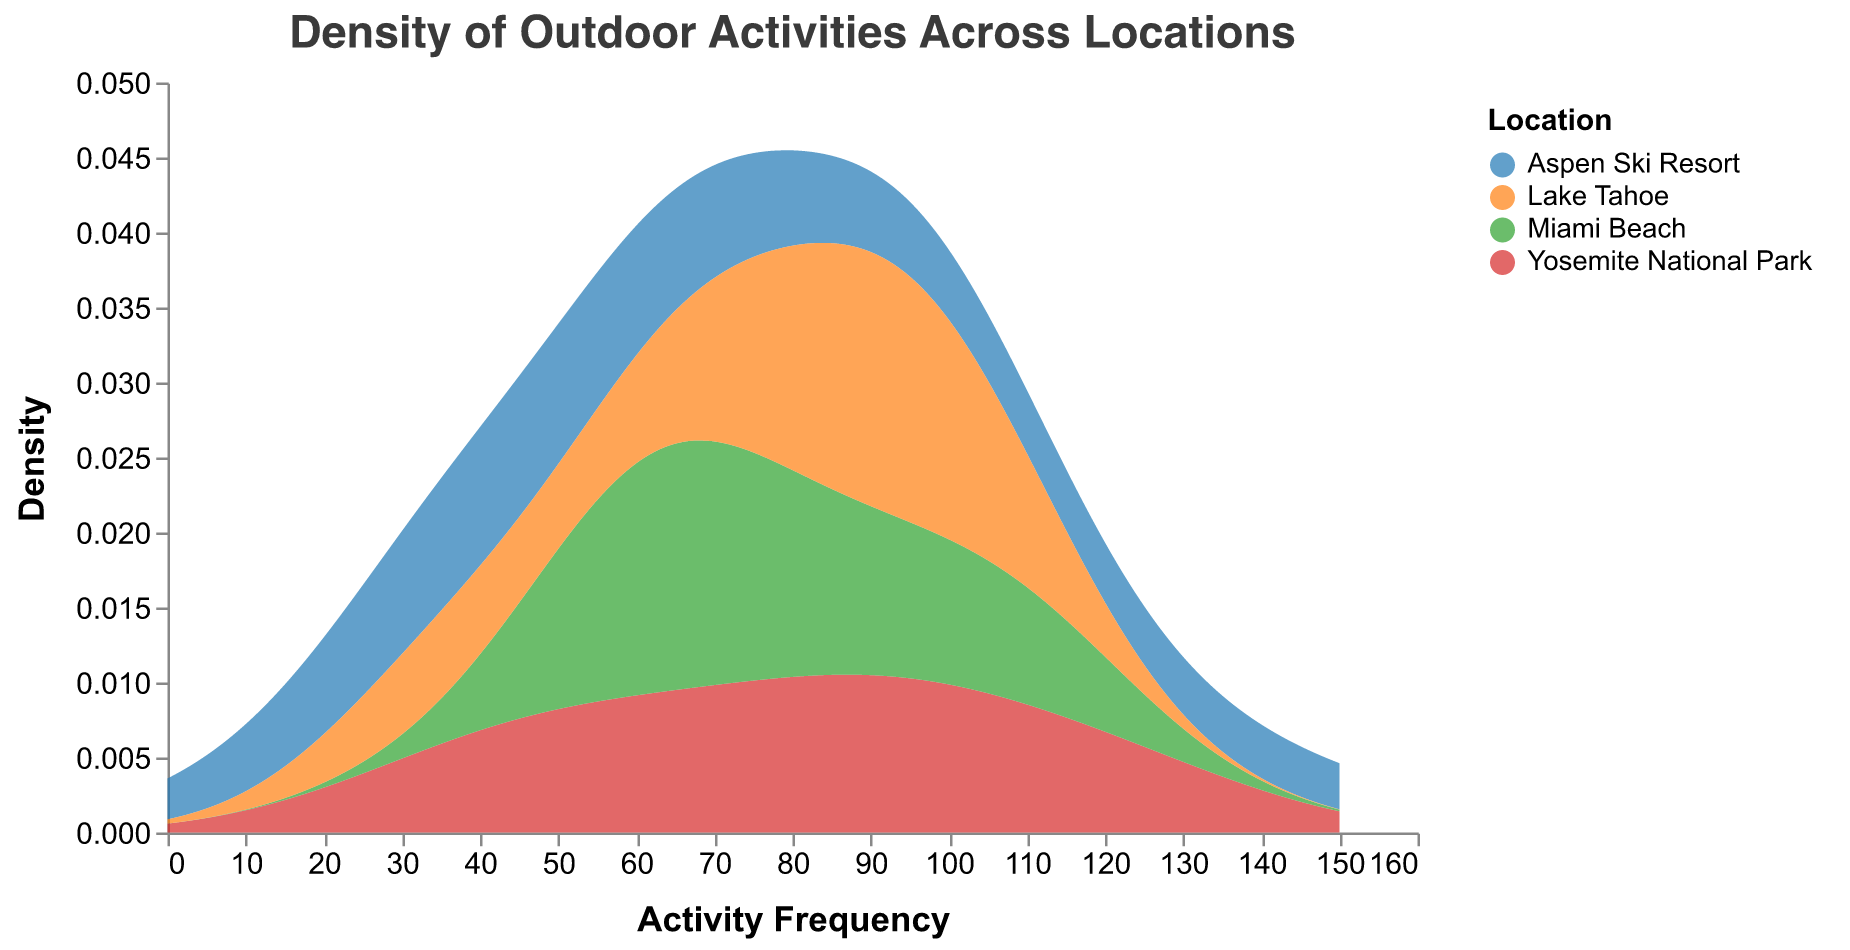What is the title of the density plot? The title can be found at the top of the figure. It reads "Density of Outdoor Activities Across Locations".
Answer: Density of Outdoor Activities Across Locations What are the different locations identified in the plot? The different locations can be found in the legend of the plot, which includes Yosemite National Park, Miami Beach, Aspen Ski Resort, and Lake Tahoe.
Answer: Yosemite National Park, Miami Beach, Aspen Ski Resort, Lake Tahoe Which location has the highest activity frequency? By examining the x-axis (Activity Frequency) and identifying the peak frequency for each location, Aspen Ski Resort has the highest peak at around 140 for the activity Skiing.
Answer: Aspen Ski Resort What is the color used to represent Yosemite National Park? The color representing Yosemite National Park can be identified from the legend, which shows it in blue.
Answer: Blue Which locations have an activity with a lower frequency density reaching close to zero? By examining the density values on the y-axis close to zero, we observe that Yosemite National Park (Bird Watching), Aspen Ski Resort (Snowshoeing), and Lake Tahoe (Bird Watching) have activities with low frequencies.
Answer: Yosemite National Park, Aspen Ski Resort, Lake Tahoe What is the most preferred activity at Yosemite National Park, and how can you tell? By examining the density curve and its peak in green (representing Yosemite), Hiking has the highest frequency at 120.
Answer: Hiking What is the median frequency of the activities at Lake Tahoe? The activities at Lake Tahoe have frequencies of 100 (Hiking), 85 (Boating), 95 (Fishing), 70 (Camping), and 35 (Bird Watching). To find the median, sort the values: 35, 70, 85, 95, 100. The median is the middle value, which is 85.
Answer: 85 Compare the frequency densities of Photography at Yosemite National Park and Aspen Ski Resort. The frequency for Photography is 95 for Yosemite National Park and 45 for Aspen Ski Resort. The density peak for Yosemite is higher and has a wider spread compared to Aspen. This indicates that Photography is more popular at Yosemite than Aspen.
Answer: Yosemite National Park has a higher density What is the range of activity frequencies considered in this density plot? The x-axis, which represents activity frequency, has a range from 0 to 150. This range is set to include all frequency values found in the data.
Answer: 0 to 150 Which location has activities closely clustered around an activity frequency of 90? Both Miami Beach and Aspen Ski Resort have activities (Snorkeling and Snowboarding, respectively) with high densities around the frequency of 90.
Answer: Miami Beach, Aspen Ski Resort 